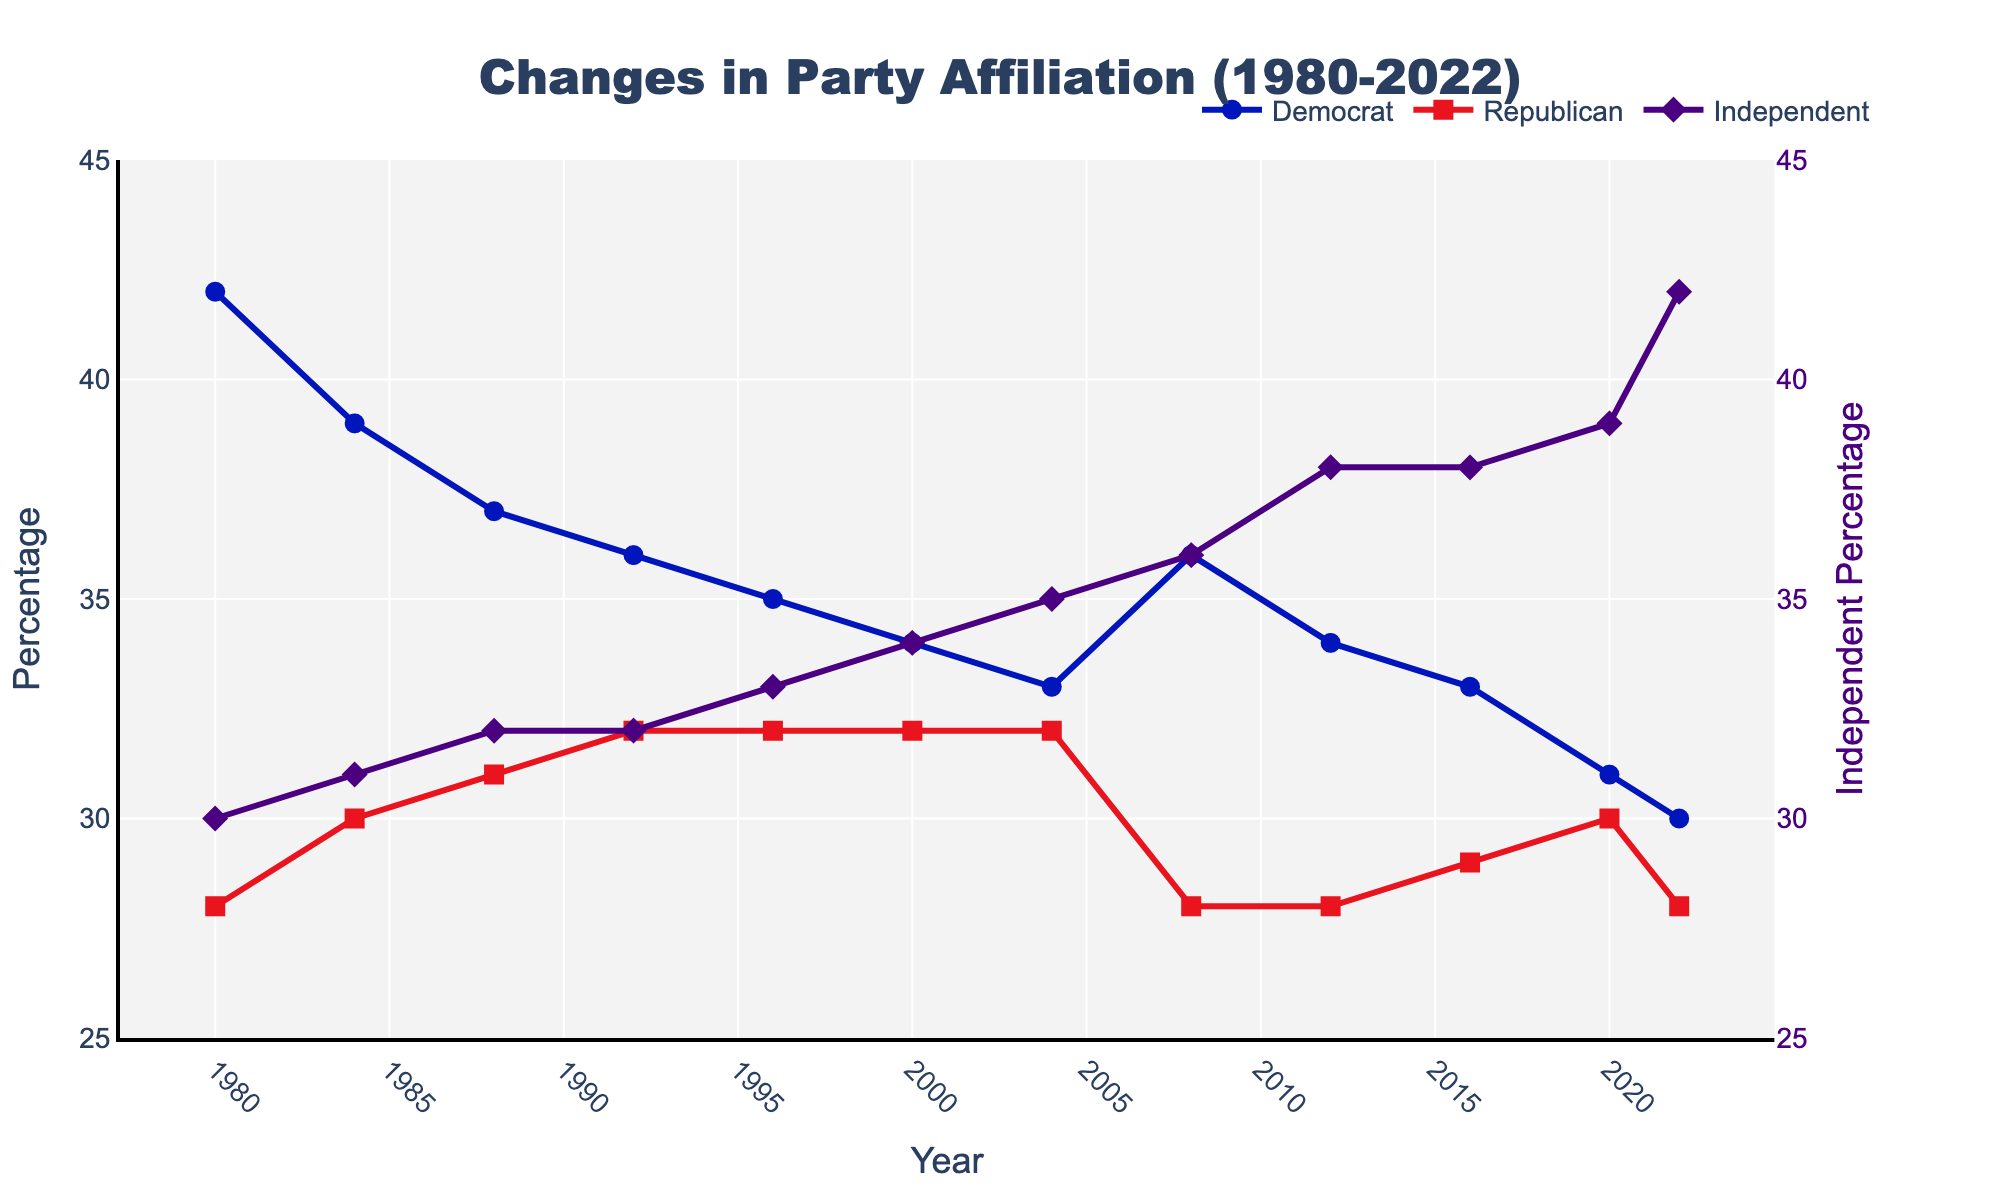What year did the Democratic party see the highest percentage among registered voters? Look at the blue line (Democrat) and check its highest point on the y-axis, noting the corresponding year on the x-axis. The highest point is in 1980.
Answer: 1980 What is the trend in the percentage for Independent voters from 1980 to 2022? Observe the purple line (Independent) and note the general direction it follows from 1980 to 2022. The line starts low and steadily increases over time.
Answer: Increasing Between 1980 and 2022, which party's percentage remained most stable? Compare the fluctuations in the lines representing Democrat (blue), Republican (red), and Independent (purple). The Republican line shows the least deviation, indicating it is the most stable.
Answer: Republican What is the average percentage of Republican voters across all the years shown? Add all the percentages for Republicans from 1980 to 2022 and divide by the number of years (12). (28 + 30 + 31 + 32 + 32 + 32 + 32 + 28 + 28 + 29 + 30 + 28) / 12 = 346 / 12 = 28.83, rounded to two decimal places.
Answer: 28.83 Which party saw the greatest decrease in percentage from 1980 to 2022? Look at the starting point in 1980 and compare it to the endpoint in 2022 for each party. Democrats start at 42% and end at 30%, a decrease of 12%. Republicans start at 28% and end at 28%, no net change. Independents start at 30% and end at 42%, a 12% increase. The Democratic party saw the greatest decrease of 12%.
Answer: Democrat In which year did Independents surpass both Democrats and Republicans in percentage? Identify where the purple line (Independent) is above both the blue line (Democrat) and red line (Republican). This happens in 2012.
Answer: 2012 What is the range of Democrat percentages from 1980 to 2022? Find the maximum (42) and minimum (30) values for the Democratic percentages and calculate the difference: 42 - 30 = 12.
Answer: 12 By how many percentage points did the percentage of Independent voters increase from 1980 to 2022? Subtract the percentage in 1980 from the percentage in 2022 for Independents: 42 - 30 = 12.
Answer: 12 